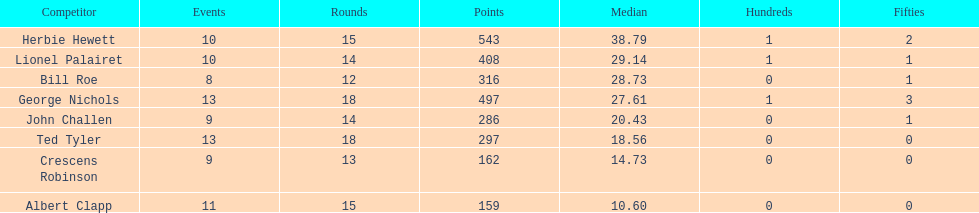How many innings did bill and ted have in total? 30. 